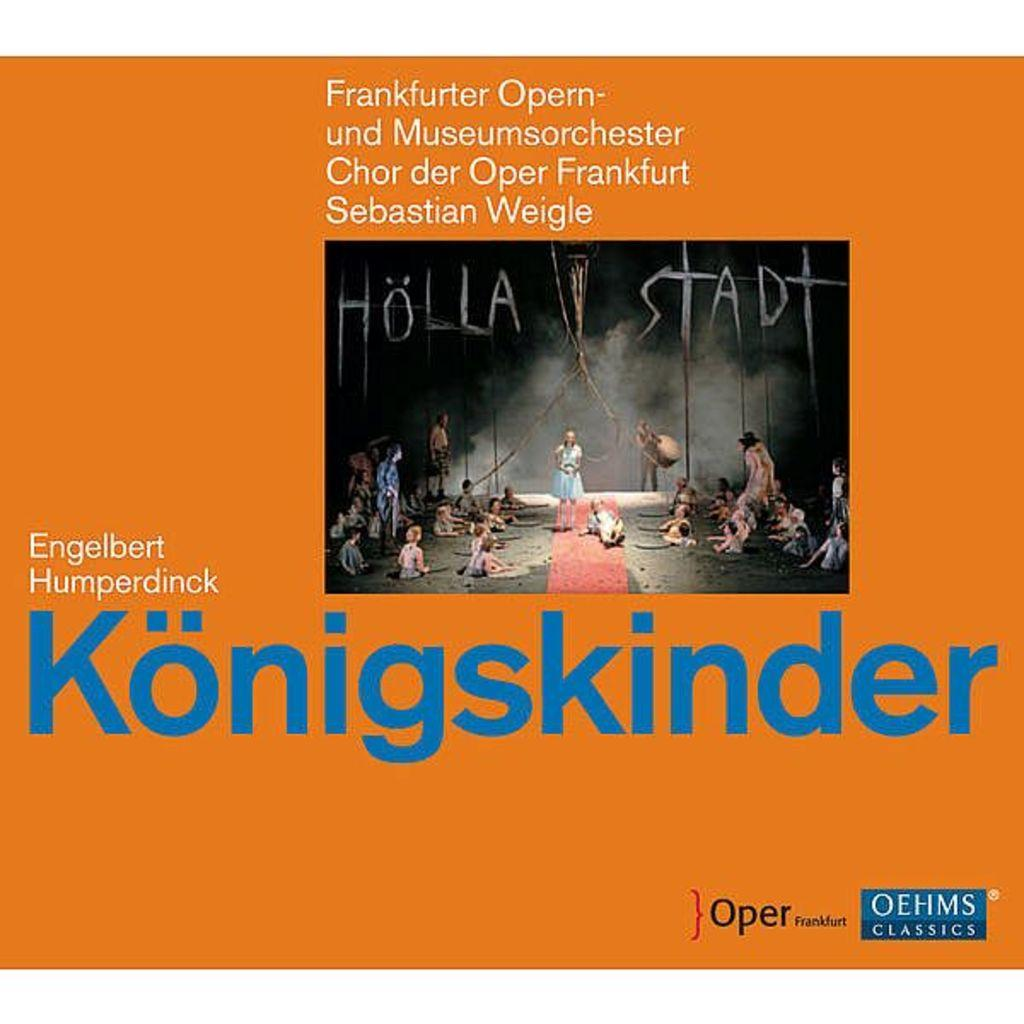<image>
Provide a brief description of the given image. Cover that says the word "Konigskinder" in blue on the front. 